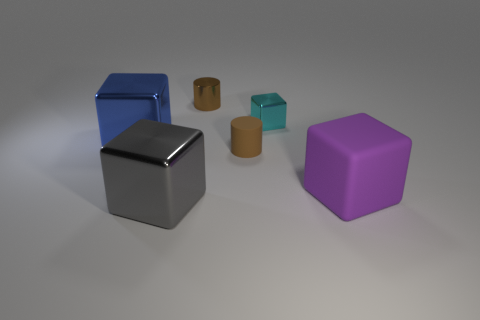Can you tell me the colors of the objects in the image? Certainly! In the image, there are objects with different colors including a blue cube, a gray cube, a purple cube, and two cuboids that appear to be shades of teal and orange. Which object appears to be the smallest? Based on the perspective given in the image, the orange cuboid appears to be the smallest object among them all. 